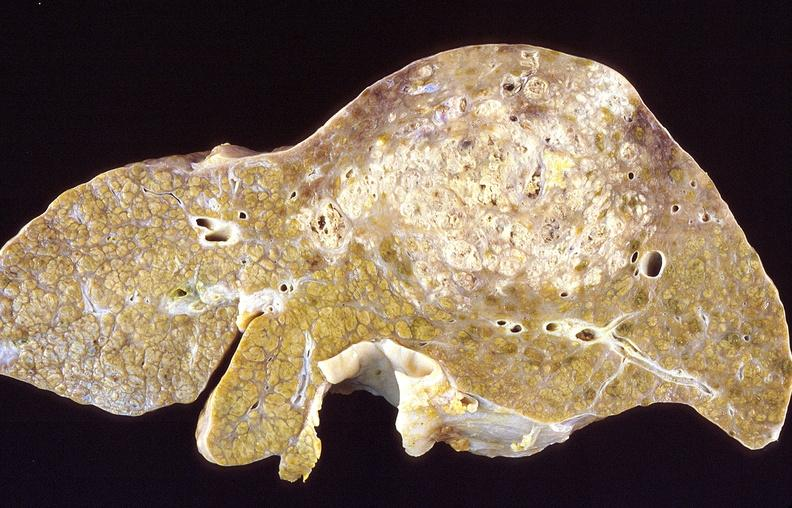does hemorrhage associated with placental abruption show hepatocellular carcinoma, hepatitis c positive?
Answer the question using a single word or phrase. No 